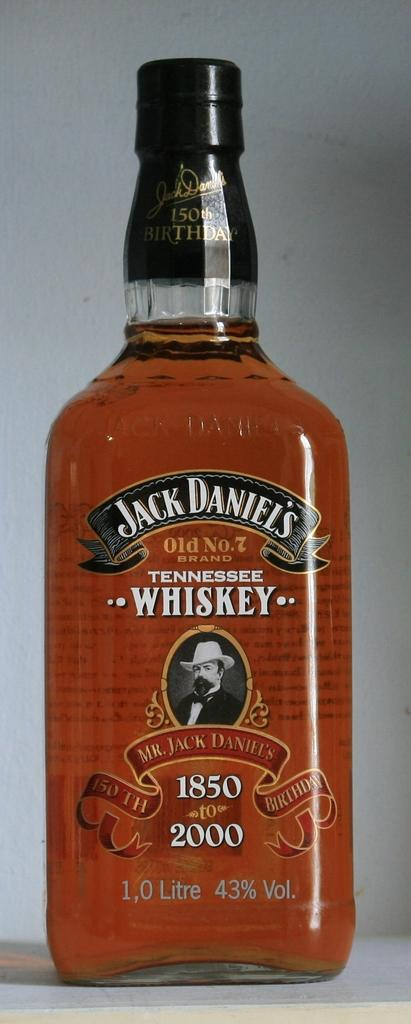Provide a one-sentence caption for the provided image. A bottle of Jack Daniel's Tennesee Whiskey sits on a table. 